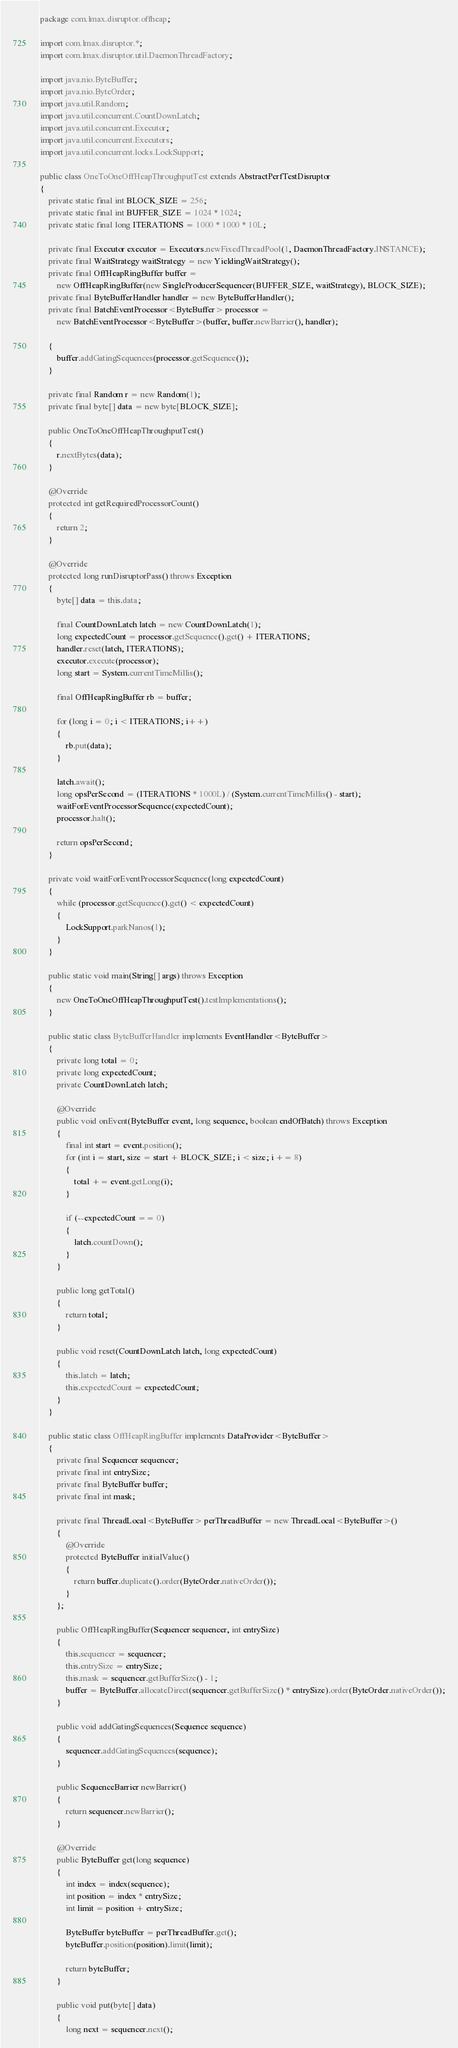<code> <loc_0><loc_0><loc_500><loc_500><_Java_>package com.lmax.disruptor.offheap;

import com.lmax.disruptor.*;
import com.lmax.disruptor.util.DaemonThreadFactory;

import java.nio.ByteBuffer;
import java.nio.ByteOrder;
import java.util.Random;
import java.util.concurrent.CountDownLatch;
import java.util.concurrent.Executor;
import java.util.concurrent.Executors;
import java.util.concurrent.locks.LockSupport;

public class OneToOneOffHeapThroughputTest extends AbstractPerfTestDisruptor
{
    private static final int BLOCK_SIZE = 256;
    private static final int BUFFER_SIZE = 1024 * 1024;
    private static final long ITERATIONS = 1000 * 1000 * 10L;

    private final Executor executor = Executors.newFixedThreadPool(1, DaemonThreadFactory.INSTANCE);
    private final WaitStrategy waitStrategy = new YieldingWaitStrategy();
    private final OffHeapRingBuffer buffer =
        new OffHeapRingBuffer(new SingleProducerSequencer(BUFFER_SIZE, waitStrategy), BLOCK_SIZE);
    private final ByteBufferHandler handler = new ByteBufferHandler();
    private final BatchEventProcessor<ByteBuffer> processor =
        new BatchEventProcessor<ByteBuffer>(buffer, buffer.newBarrier(), handler);

    {
        buffer.addGatingSequences(processor.getSequence());
    }

    private final Random r = new Random(1);
    private final byte[] data = new byte[BLOCK_SIZE];

    public OneToOneOffHeapThroughputTest()
    {
        r.nextBytes(data);
    }

    @Override
    protected int getRequiredProcessorCount()
    {
        return 2;
    }

    @Override
    protected long runDisruptorPass() throws Exception
    {
        byte[] data = this.data;

        final CountDownLatch latch = new CountDownLatch(1);
        long expectedCount = processor.getSequence().get() + ITERATIONS;
        handler.reset(latch, ITERATIONS);
        executor.execute(processor);
        long start = System.currentTimeMillis();

        final OffHeapRingBuffer rb = buffer;

        for (long i = 0; i < ITERATIONS; i++)
        {
            rb.put(data);
        }

        latch.await();
        long opsPerSecond = (ITERATIONS * 1000L) / (System.currentTimeMillis() - start);
        waitForEventProcessorSequence(expectedCount);
        processor.halt();

        return opsPerSecond;
    }

    private void waitForEventProcessorSequence(long expectedCount)
    {
        while (processor.getSequence().get() < expectedCount)
        {
            LockSupport.parkNanos(1);
        }
    }

    public static void main(String[] args) throws Exception
    {
        new OneToOneOffHeapThroughputTest().testImplementations();
    }

    public static class ByteBufferHandler implements EventHandler<ByteBuffer>
    {
        private long total = 0;
        private long expectedCount;
        private CountDownLatch latch;

        @Override
        public void onEvent(ByteBuffer event, long sequence, boolean endOfBatch) throws Exception
        {
            final int start = event.position();
            for (int i = start, size = start + BLOCK_SIZE; i < size; i += 8)
            {
                total += event.getLong(i);
            }

            if (--expectedCount == 0)
            {
                latch.countDown();
            }
        }

        public long getTotal()
        {
            return total;
        }

        public void reset(CountDownLatch latch, long expectedCount)
        {
            this.latch = latch;
            this.expectedCount = expectedCount;
        }
    }

    public static class OffHeapRingBuffer implements DataProvider<ByteBuffer>
    {
        private final Sequencer sequencer;
        private final int entrySize;
        private final ByteBuffer buffer;
        private final int mask;

        private final ThreadLocal<ByteBuffer> perThreadBuffer = new ThreadLocal<ByteBuffer>()
        {
            @Override
            protected ByteBuffer initialValue()
            {
                return buffer.duplicate().order(ByteOrder.nativeOrder());
            }
        };

        public OffHeapRingBuffer(Sequencer sequencer, int entrySize)
        {
            this.sequencer = sequencer;
            this.entrySize = entrySize;
            this.mask = sequencer.getBufferSize() - 1;
            buffer = ByteBuffer.allocateDirect(sequencer.getBufferSize() * entrySize).order(ByteOrder.nativeOrder());
        }

        public void addGatingSequences(Sequence sequence)
        {
            sequencer.addGatingSequences(sequence);
        }

        public SequenceBarrier newBarrier()
        {
            return sequencer.newBarrier();
        }

        @Override
        public ByteBuffer get(long sequence)
        {
            int index = index(sequence);
            int position = index * entrySize;
            int limit = position + entrySize;

            ByteBuffer byteBuffer = perThreadBuffer.get();
            byteBuffer.position(position).limit(limit);

            return byteBuffer;
        }

        public void put(byte[] data)
        {
            long next = sequencer.next();</code> 